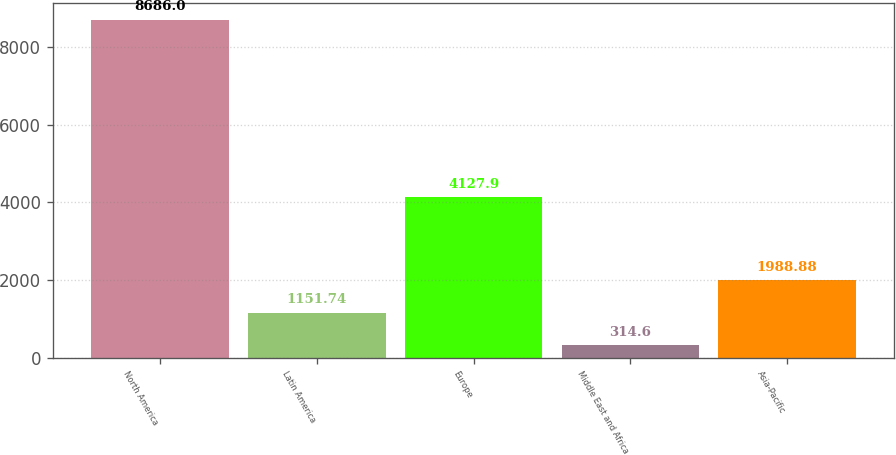Convert chart to OTSL. <chart><loc_0><loc_0><loc_500><loc_500><bar_chart><fcel>North America<fcel>Latin America<fcel>Europe<fcel>Middle East and Africa<fcel>Asia-Pacific<nl><fcel>8686<fcel>1151.74<fcel>4127.9<fcel>314.6<fcel>1988.88<nl></chart> 